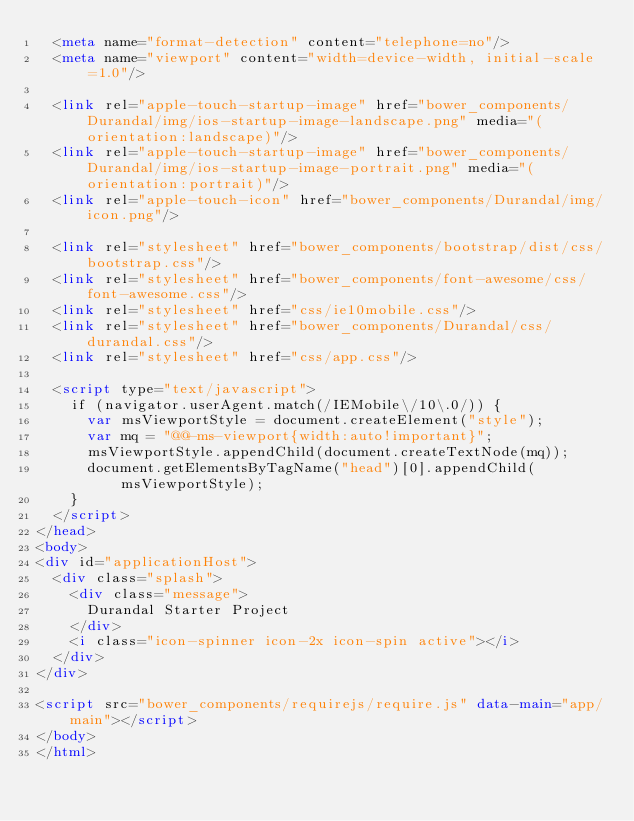Convert code to text. <code><loc_0><loc_0><loc_500><loc_500><_HTML_>  <meta name="format-detection" content="telephone=no"/>
  <meta name="viewport" content="width=device-width, initial-scale=1.0"/>

  <link rel="apple-touch-startup-image" href="bower_components/Durandal/img/ios-startup-image-landscape.png" media="(orientation:landscape)"/>
  <link rel="apple-touch-startup-image" href="bower_components/Durandal/img/ios-startup-image-portrait.png" media="(orientation:portrait)"/>
  <link rel="apple-touch-icon" href="bower_components/Durandal/img/icon.png"/>

  <link rel="stylesheet" href="bower_components/bootstrap/dist/css/bootstrap.css"/>
  <link rel="stylesheet" href="bower_components/font-awesome/css/font-awesome.css"/>
  <link rel="stylesheet" href="css/ie10mobile.css"/>
  <link rel="stylesheet" href="bower_components/Durandal/css/durandal.css"/>
  <link rel="stylesheet" href="css/app.css"/>

  <script type="text/javascript">
    if (navigator.userAgent.match(/IEMobile\/10\.0/)) {
      var msViewportStyle = document.createElement("style");
      var mq = "@@-ms-viewport{width:auto!important}";
      msViewportStyle.appendChild(document.createTextNode(mq));
      document.getElementsByTagName("head")[0].appendChild(msViewportStyle);
    }
  </script>
</head>
<body>
<div id="applicationHost">
  <div class="splash">
    <div class="message">
      Durandal Starter Project
    </div>
    <i class="icon-spinner icon-2x icon-spin active"></i>
  </div>
</div>

<script src="bower_components/requirejs/require.js" data-main="app/main"></script>
</body>
</html>
</code> 